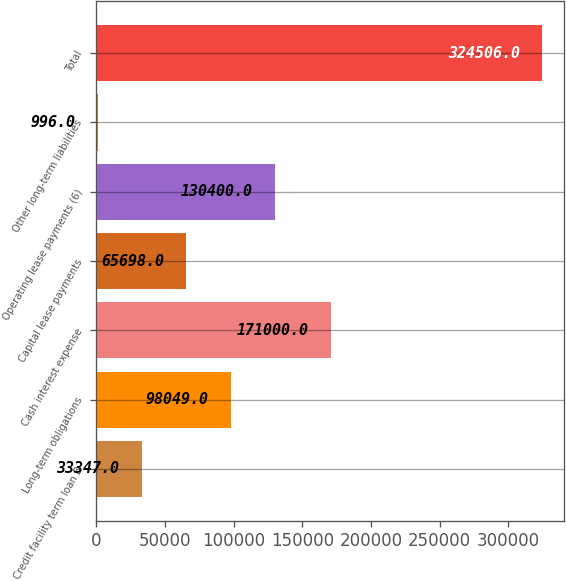<chart> <loc_0><loc_0><loc_500><loc_500><bar_chart><fcel>Credit facility term loan B<fcel>Long-term obligations<fcel>Cash interest expense<fcel>Capital lease payments<fcel>Operating lease payments (6)<fcel>Other long-term liabilities<fcel>Total<nl><fcel>33347<fcel>98049<fcel>171000<fcel>65698<fcel>130400<fcel>996<fcel>324506<nl></chart> 